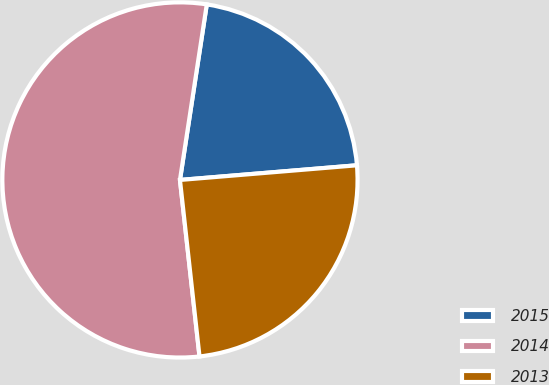<chart> <loc_0><loc_0><loc_500><loc_500><pie_chart><fcel>2015<fcel>2014<fcel>2013<nl><fcel>21.27%<fcel>54.17%<fcel>24.56%<nl></chart> 